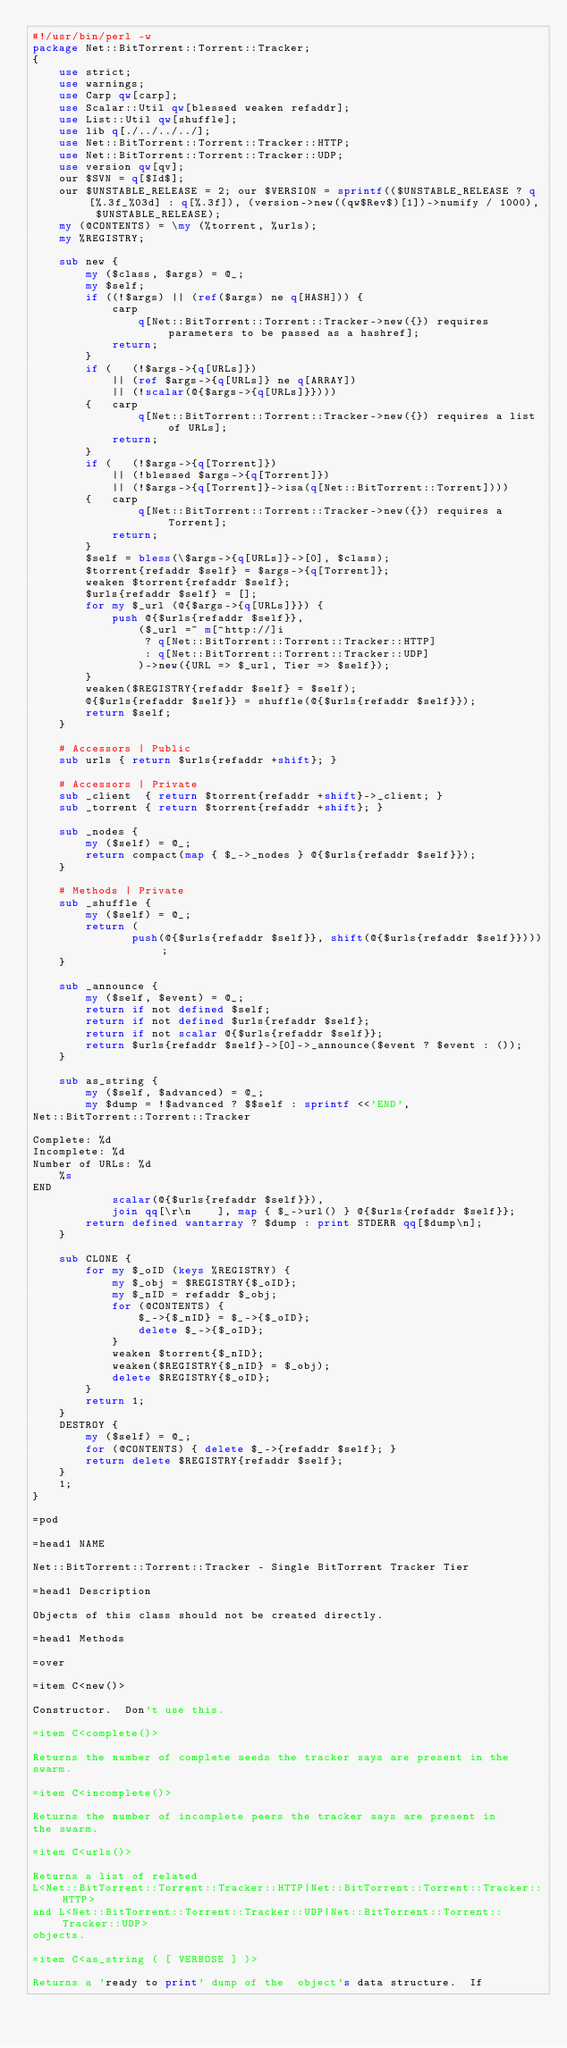<code> <loc_0><loc_0><loc_500><loc_500><_Perl_>#!/usr/bin/perl -w
package Net::BitTorrent::Torrent::Tracker;
{
    use strict;
    use warnings;
    use Carp qw[carp];
    use Scalar::Util qw[blessed weaken refaddr];
    use List::Util qw[shuffle];
    use lib q[./../../../];
    use Net::BitTorrent::Torrent::Tracker::HTTP;
    use Net::BitTorrent::Torrent::Tracker::UDP;
    use version qw[qv];
    our $SVN = q[$Id$];
    our $UNSTABLE_RELEASE = 2; our $VERSION = sprintf(($UNSTABLE_RELEASE ? q[%.3f_%03d] : q[%.3f]), (version->new((qw$Rev$)[1])->numify / 1000), $UNSTABLE_RELEASE);
    my (@CONTENTS) = \my (%torrent, %urls);
    my %REGISTRY;

    sub new {
        my ($class, $args) = @_;
        my $self;
        if ((!$args) || (ref($args) ne q[HASH])) {
            carp
                q[Net::BitTorrent::Torrent::Tracker->new({}) requires parameters to be passed as a hashref];
            return;
        }
        if (   (!$args->{q[URLs]})
            || (ref $args->{q[URLs]} ne q[ARRAY])
            || (!scalar(@{$args->{q[URLs]}})))
        {   carp
                q[Net::BitTorrent::Torrent::Tracker->new({}) requires a list of URLs];
            return;
        }
        if (   (!$args->{q[Torrent]})
            || (!blessed $args->{q[Torrent]})
            || (!$args->{q[Torrent]}->isa(q[Net::BitTorrent::Torrent])))
        {   carp
                q[Net::BitTorrent::Torrent::Tracker->new({}) requires a Torrent];
            return;
        }
        $self = bless(\$args->{q[URLs]}->[0], $class);
        $torrent{refaddr $self} = $args->{q[Torrent]};
        weaken $torrent{refaddr $self};
        $urls{refaddr $self} = [];
        for my $_url (@{$args->{q[URLs]}}) {
            push @{$urls{refaddr $self}},
                ($_url =~ m[^http://]i
                 ? q[Net::BitTorrent::Torrent::Tracker::HTTP]
                 : q[Net::BitTorrent::Torrent::Tracker::UDP]
                )->new({URL => $_url, Tier => $self});
        }
        weaken($REGISTRY{refaddr $self} = $self);
        @{$urls{refaddr $self}} = shuffle(@{$urls{refaddr $self}});
        return $self;
    }

    # Accessors | Public
    sub urls { return $urls{refaddr +shift}; }

    # Accessors | Private
    sub _client  { return $torrent{refaddr +shift}->_client; }
    sub _torrent { return $torrent{refaddr +shift}; }

    sub _nodes {
        my ($self) = @_;
        return compact(map { $_->_nodes } @{$urls{refaddr $self}});
    }

    # Methods | Private
    sub _shuffle {
        my ($self) = @_;
        return (
               push(@{$urls{refaddr $self}}, shift(@{$urls{refaddr $self}})));
    }

    sub _announce {
        my ($self, $event) = @_;
        return if not defined $self;
        return if not defined $urls{refaddr $self};
        return if not scalar @{$urls{refaddr $self}};
        return $urls{refaddr $self}->[0]->_announce($event ? $event : ());
    }

    sub as_string {
        my ($self, $advanced) = @_;
        my $dump = !$advanced ? $$self : sprintf <<'END',
Net::BitTorrent::Torrent::Tracker

Complete: %d
Incomplete: %d
Number of URLs: %d
    %s
END
            scalar(@{$urls{refaddr $self}}),
            join qq[\r\n    ], map { $_->url() } @{$urls{refaddr $self}};
        return defined wantarray ? $dump : print STDERR qq[$dump\n];
    }

    sub CLONE {
        for my $_oID (keys %REGISTRY) {
            my $_obj = $REGISTRY{$_oID};
            my $_nID = refaddr $_obj;
            for (@CONTENTS) {
                $_->{$_nID} = $_->{$_oID};
                delete $_->{$_oID};
            }
            weaken $torrent{$_nID};
            weaken($REGISTRY{$_nID} = $_obj);
            delete $REGISTRY{$_oID};
        }
        return 1;
    }
    DESTROY {
        my ($self) = @_;
        for (@CONTENTS) { delete $_->{refaddr $self}; }
        return delete $REGISTRY{refaddr $self};
    }
    1;
}

=pod

=head1 NAME

Net::BitTorrent::Torrent::Tracker - Single BitTorrent Tracker Tier

=head1 Description

Objects of this class should not be created directly.

=head1 Methods

=over

=item C<new()>

Constructor.  Don't use this.

=item C<complete()>

Returns the number of complete seeds the tracker says are present in the
swarm.

=item C<incomplete()>

Returns the number of incomplete peers the tracker says are present in
the swarm.

=item C<urls()>

Returns a list of related
L<Net::BitTorrent::Torrent::Tracker::HTTP|Net::BitTorrent::Torrent::Tracker::HTTP>
and L<Net::BitTorrent::Torrent::Tracker::UDP|Net::BitTorrent::Torrent::Tracker::UDP>
objects.

=item C<as_string ( [ VERBOSE ] )>

Returns a 'ready to print' dump of the  object's data structure.  If</code> 